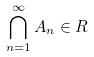Convert formula to latex. <formula><loc_0><loc_0><loc_500><loc_500>\bigcap _ { n = 1 } ^ { \infty } A _ { n } \in R</formula> 